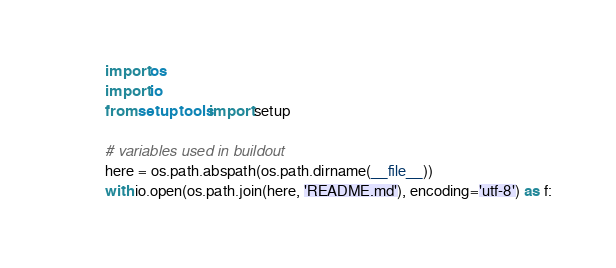Convert code to text. <code><loc_0><loc_0><loc_500><loc_500><_Python_>import os
import io
from setuptools import setup

# variables used in buildout
here = os.path.abspath(os.path.dirname(__file__))
with io.open(os.path.join(here, 'README.md'), encoding='utf-8') as f:</code> 